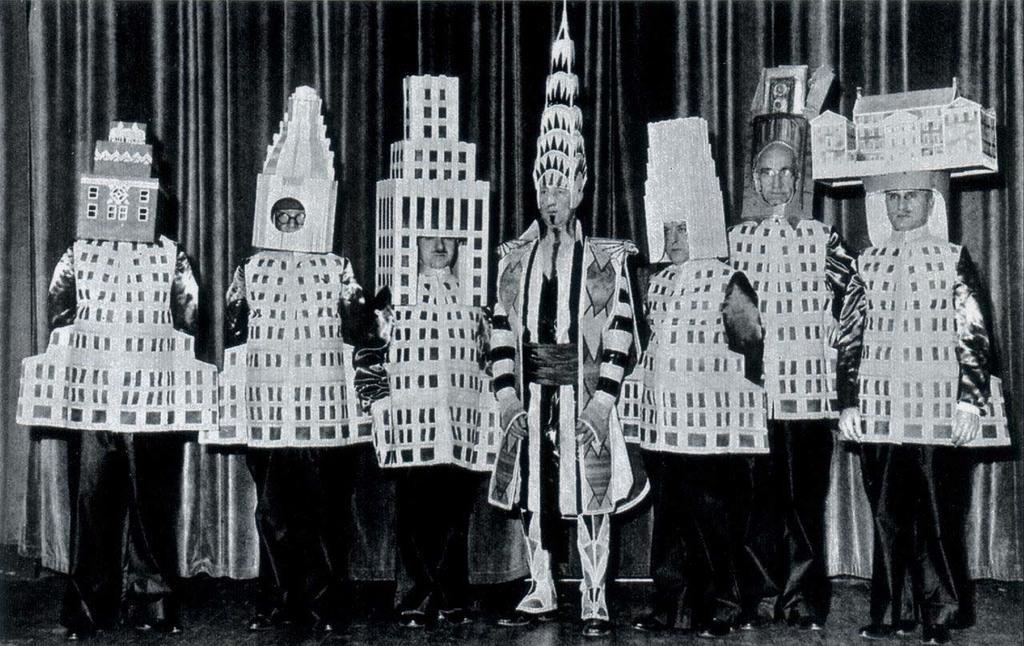In one or two sentences, can you explain what this image depicts? This picture seems to be clicked inside. In the center we can see the group of people wearing same dresses and some objects and standing on the ground. In the background we can see the curtains. 